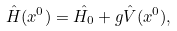<formula> <loc_0><loc_0><loc_500><loc_500>\hat { H } ( x ^ { 0 } ) = \hat { H _ { 0 } } + g \hat { V } ( x ^ { 0 } ) ,</formula> 